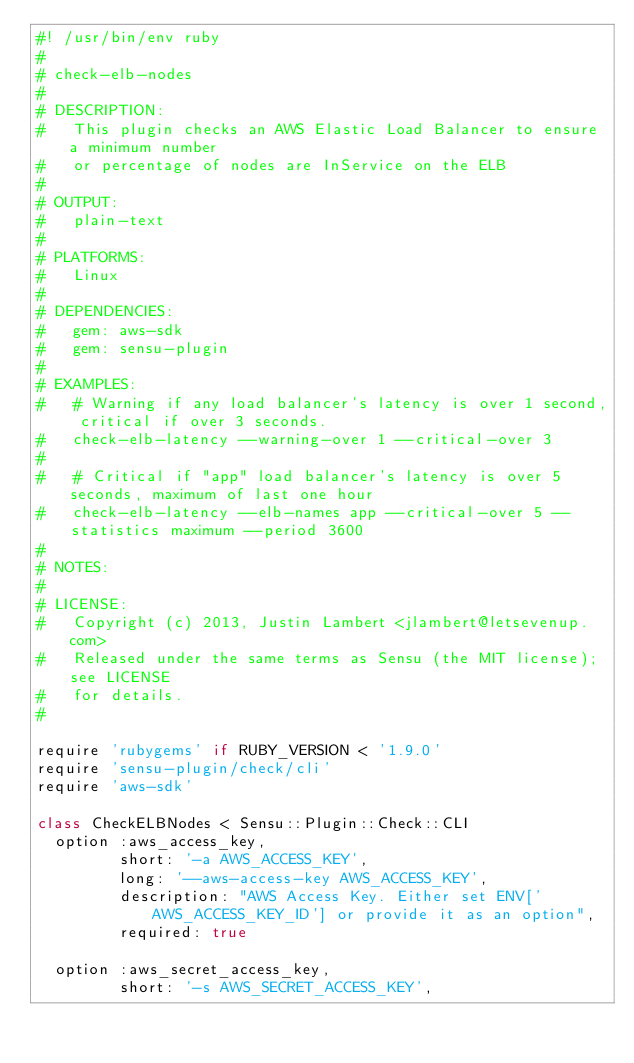Convert code to text. <code><loc_0><loc_0><loc_500><loc_500><_Ruby_>#! /usr/bin/env ruby
#
# check-elb-nodes
#
# DESCRIPTION:
#   This plugin checks an AWS Elastic Load Balancer to ensure a minimum number
#   or percentage of nodes are InService on the ELB
#
# OUTPUT:
#   plain-text
#
# PLATFORMS:
#   Linux
#
# DEPENDENCIES:
#   gem: aws-sdk
#   gem: sensu-plugin
#
# EXAMPLES:
#   # Warning if any load balancer's latency is over 1 second, critical if over 3 seconds.
#   check-elb-latency --warning-over 1 --critical-over 3
#
#   # Critical if "app" load balancer's latency is over 5 seconds, maximum of last one hour
#   check-elb-latency --elb-names app --critical-over 5 --statistics maximum --period 3600
#
# NOTES:
#
# LICENSE:
#   Copyright (c) 2013, Justin Lambert <jlambert@letsevenup.com>
#   Released under the same terms as Sensu (the MIT license); see LICENSE
#   for details.
#

require 'rubygems' if RUBY_VERSION < '1.9.0'
require 'sensu-plugin/check/cli'
require 'aws-sdk'

class CheckELBNodes < Sensu::Plugin::Check::CLI
  option :aws_access_key,
         short: '-a AWS_ACCESS_KEY',
         long: '--aws-access-key AWS_ACCESS_KEY',
         description: "AWS Access Key. Either set ENV['AWS_ACCESS_KEY_ID'] or provide it as an option",
         required: true

  option :aws_secret_access_key,
         short: '-s AWS_SECRET_ACCESS_KEY',</code> 